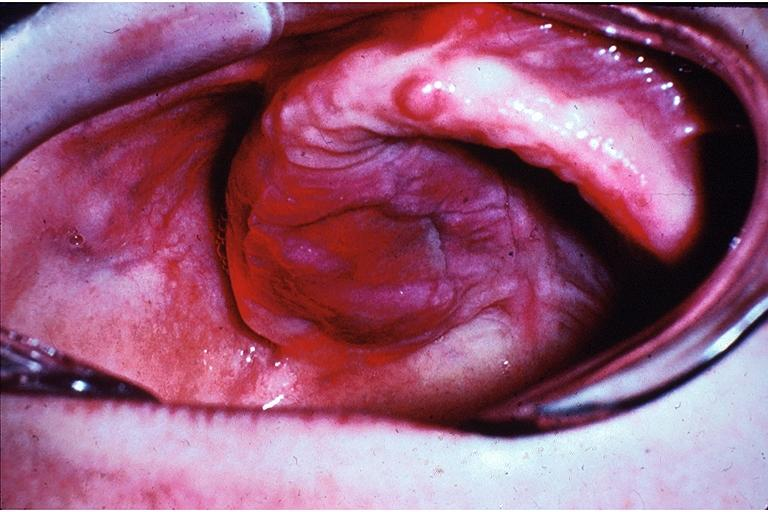s oral present?
Answer the question using a single word or phrase. Yes 